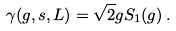<formula> <loc_0><loc_0><loc_500><loc_500>\gamma ( g , s , L ) = \sqrt { 2 } g S _ { 1 } ( g ) \, .</formula> 